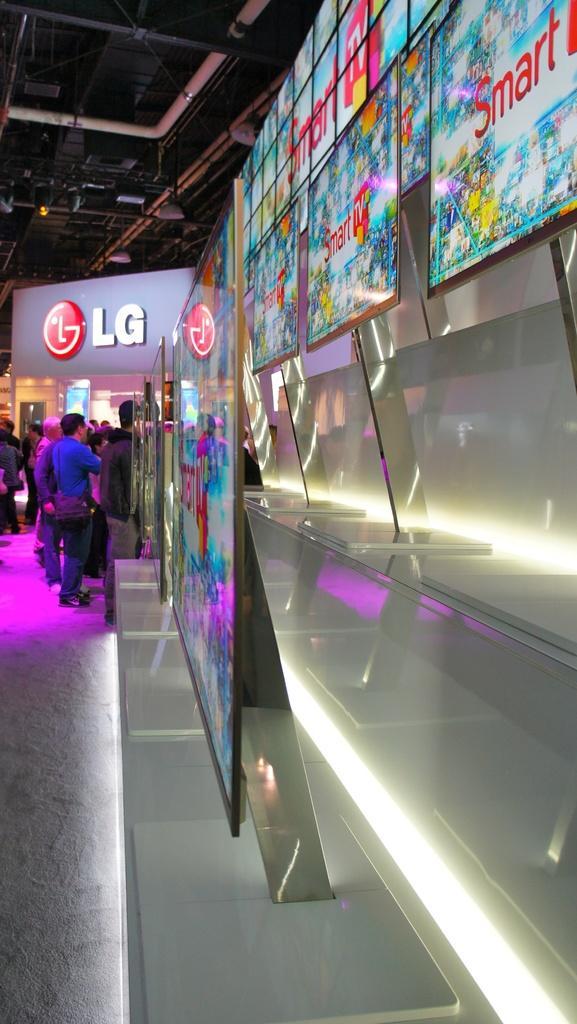How would you summarize this image in a sentence or two? In this image we can see group of people are standing, there are the televisions, there is the light, at above here is the roof. 